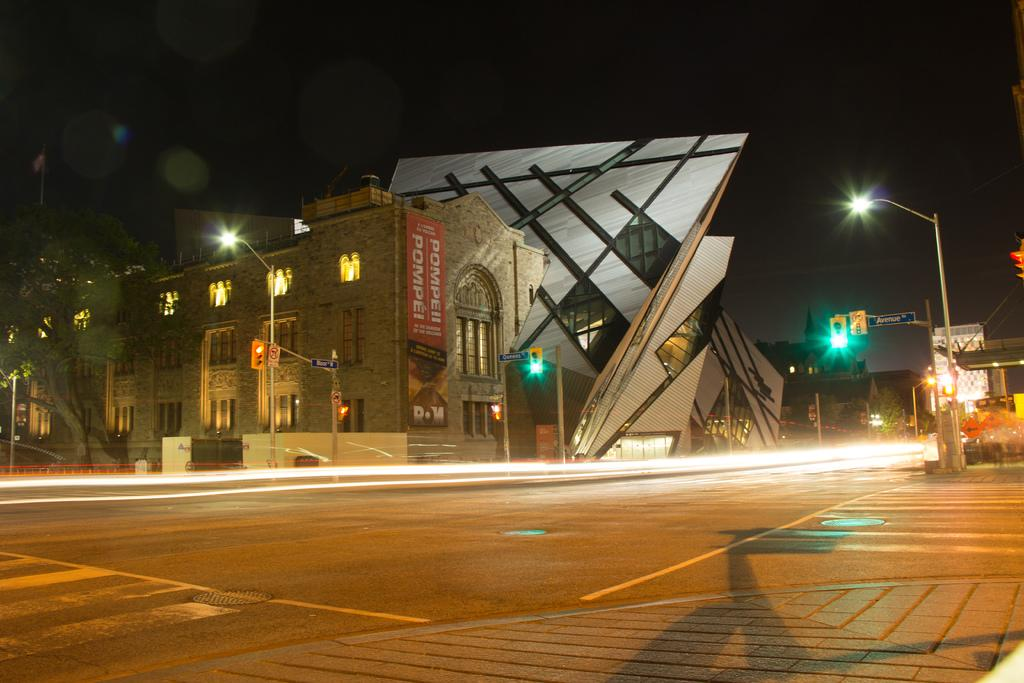What type of structures can be seen in the image? There are buildings in the image. What other natural elements are present in the image? There are trees in the image. What type of lighting is present in the image? There are pole lights in the image. What type of signals are present on the poles? There are traffic signal lights on the poles. How many minutes does it take for the crow to fly across the image? There is no crow present in the image, so it is not possible to determine how long it would take for a crow to fly across the image. 